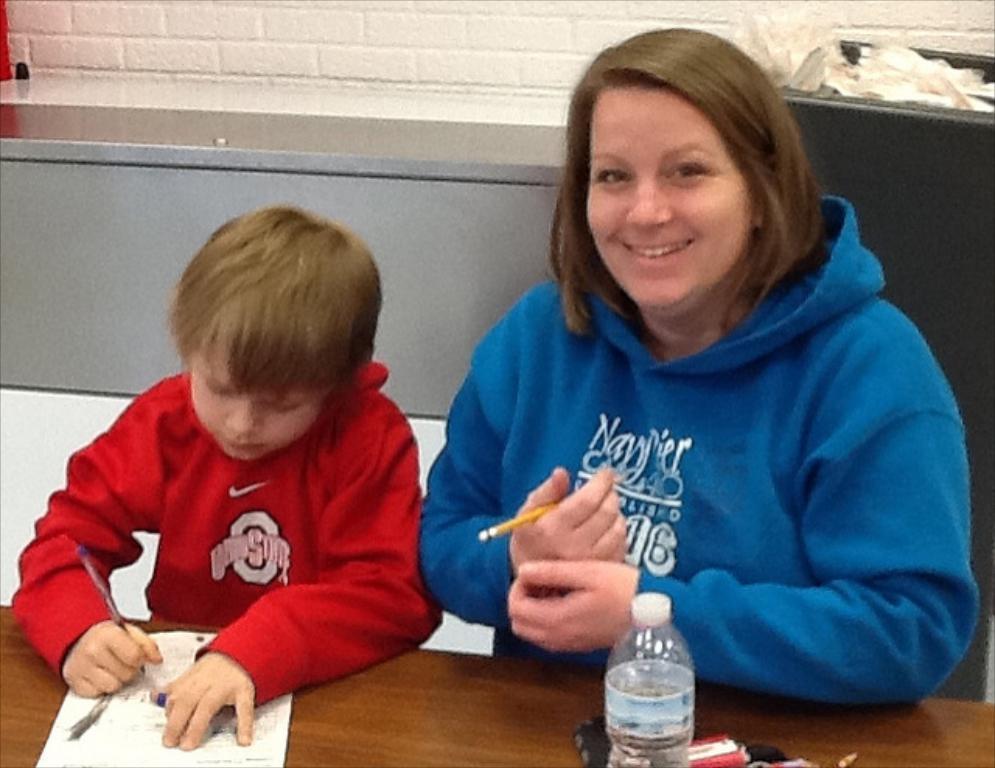In one or two sentences, can you explain what this image depicts? To the right there is a lady with blue jacket. And to the left there is a boy with red jacket. In front of them there is a table. On the table there are some paper is there and bottle. A boy is writing something on the paper with his pen. And a lady is holding pencil in her hand. 